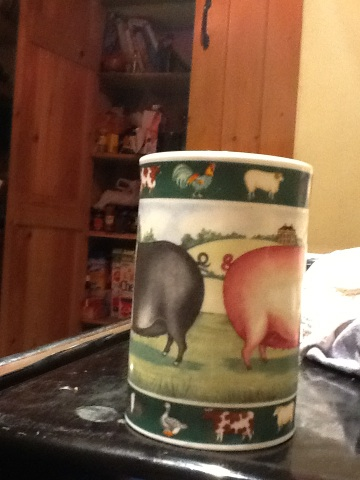What is it? This appears to be a cylindrical cup or mug with a decorative design featuring farm animals. The design on the cup includes the rear ends of a black pig and a pink pig in a pastoral setting, along with other farm-themed illustrations. 